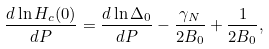<formula> <loc_0><loc_0><loc_500><loc_500>\frac { d \ln H _ { c } ( 0 ) } { d P } = \frac { d \ln \Delta _ { 0 } } { d P } - \frac { \gamma _ { N } } { 2 B _ { 0 } } + \frac { 1 } { 2 B _ { 0 } } ,</formula> 